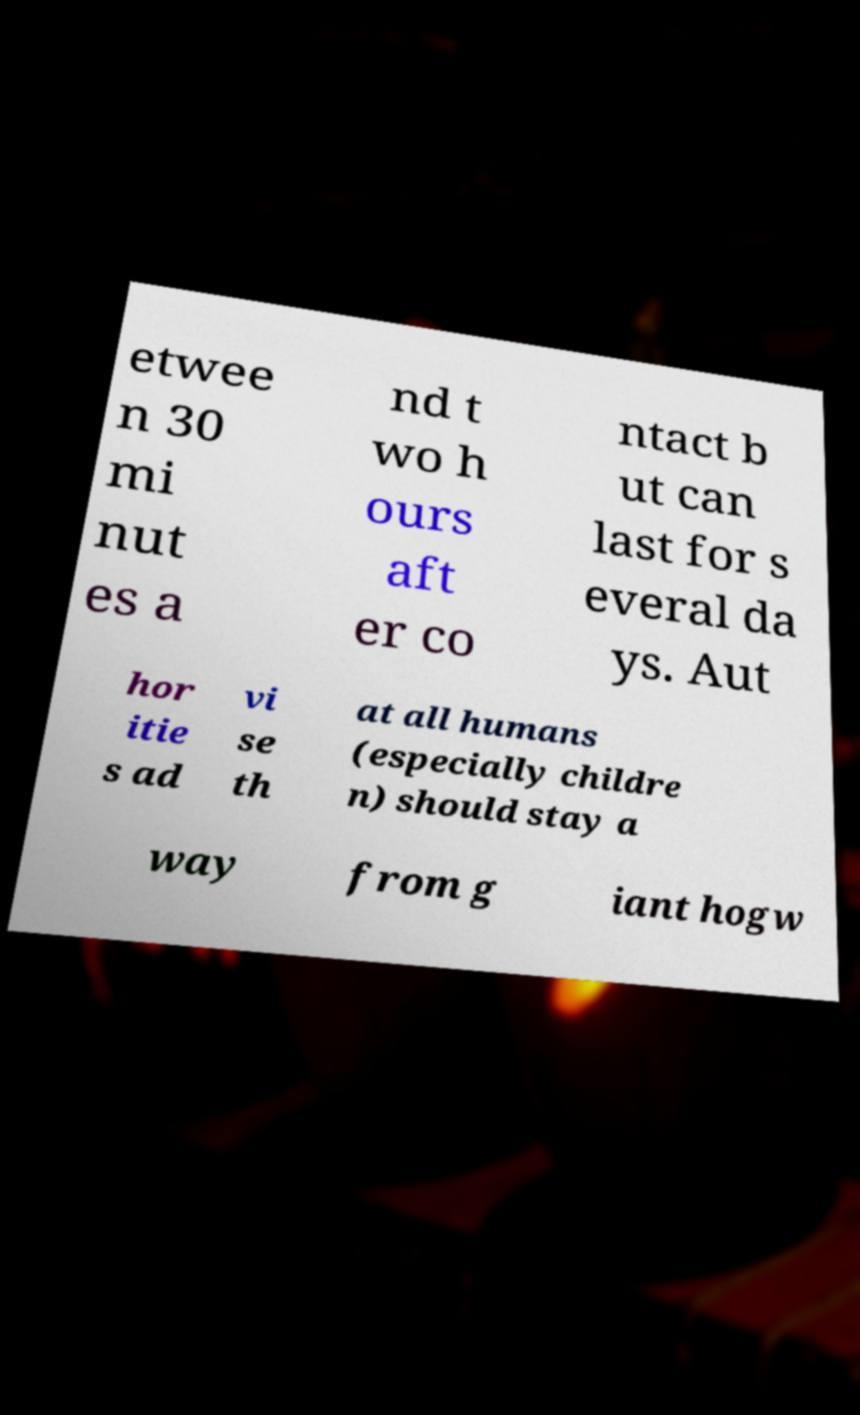Can you read and provide the text displayed in the image?This photo seems to have some interesting text. Can you extract and type it out for me? etwee n 30 mi nut es a nd t wo h ours aft er co ntact b ut can last for s everal da ys. Aut hor itie s ad vi se th at all humans (especially childre n) should stay a way from g iant hogw 